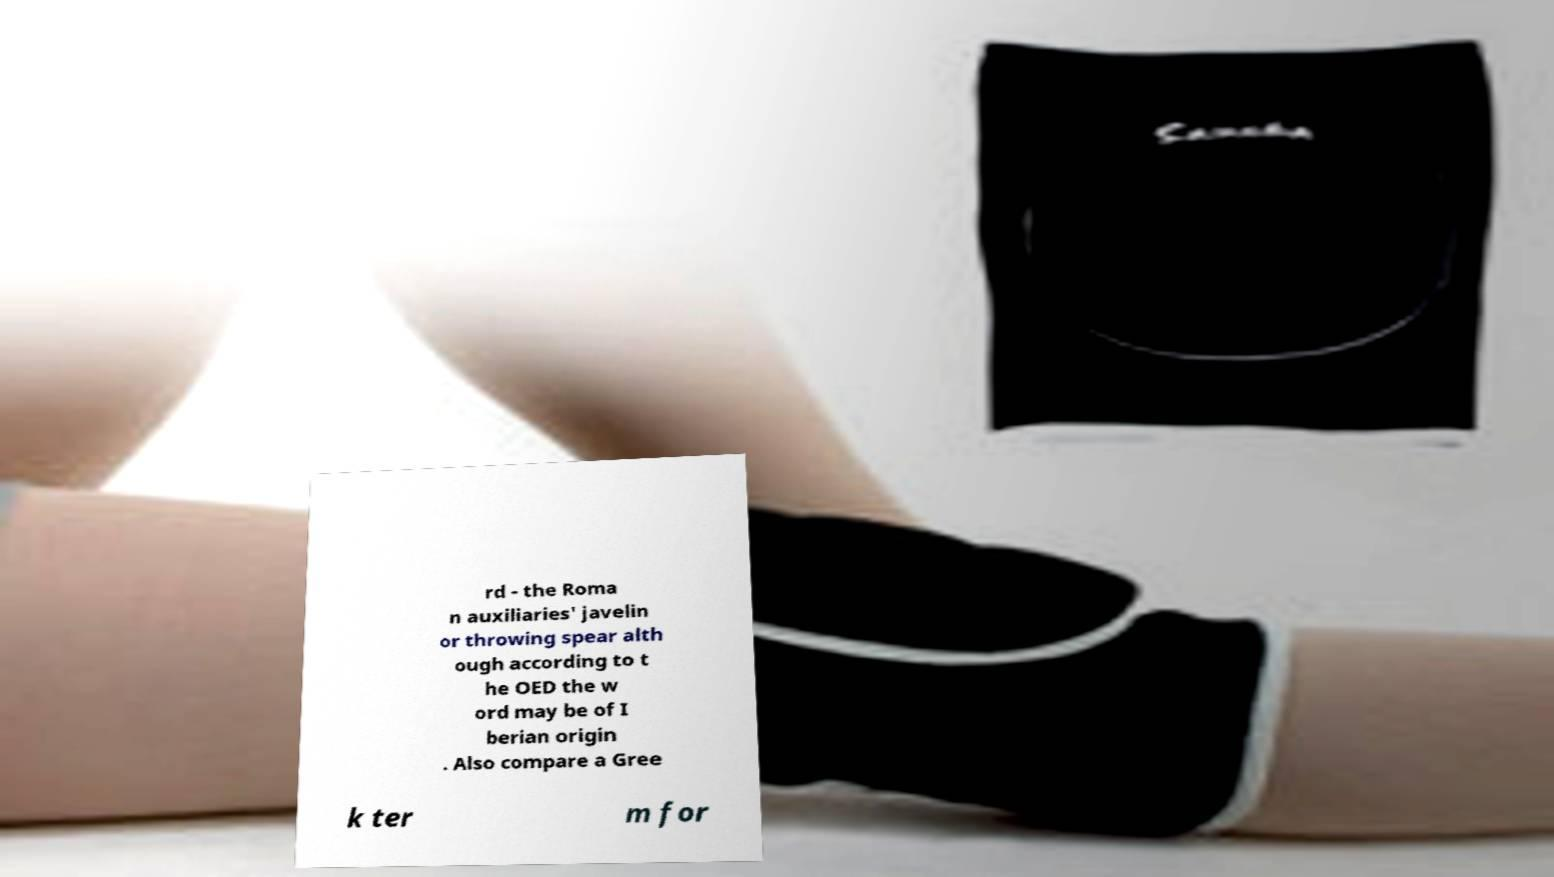Could you assist in decoding the text presented in this image and type it out clearly? rd - the Roma n auxiliaries' javelin or throwing spear alth ough according to t he OED the w ord may be of I berian origin . Also compare a Gree k ter m for 